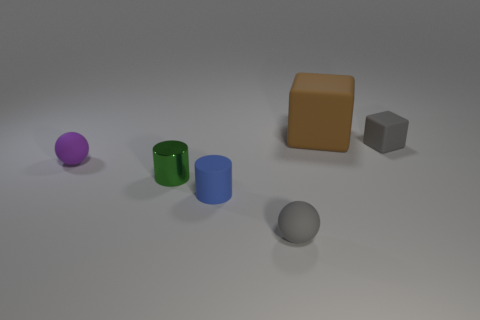How many green objects have the same size as the brown object?
Provide a short and direct response. 0. There is a small thing that is the same color as the tiny matte cube; what shape is it?
Provide a succinct answer. Sphere. Are there any tiny rubber blocks?
Give a very brief answer. Yes. There is a gray thing that is to the right of the tiny gray sphere; is its shape the same as the tiny thing that is left of the green object?
Ensure brevity in your answer.  No. What number of tiny objects are either green metallic cylinders or brown objects?
Ensure brevity in your answer.  1. There is a blue thing that is the same material as the small purple ball; what is its shape?
Provide a succinct answer. Cylinder. Is the large brown object the same shape as the blue object?
Keep it short and to the point. No. The large rubber block is what color?
Your answer should be compact. Brown. What number of objects are gray blocks or tiny gray metallic spheres?
Provide a short and direct response. 1. Is there any other thing that is the same material as the green thing?
Your answer should be very brief. No. 